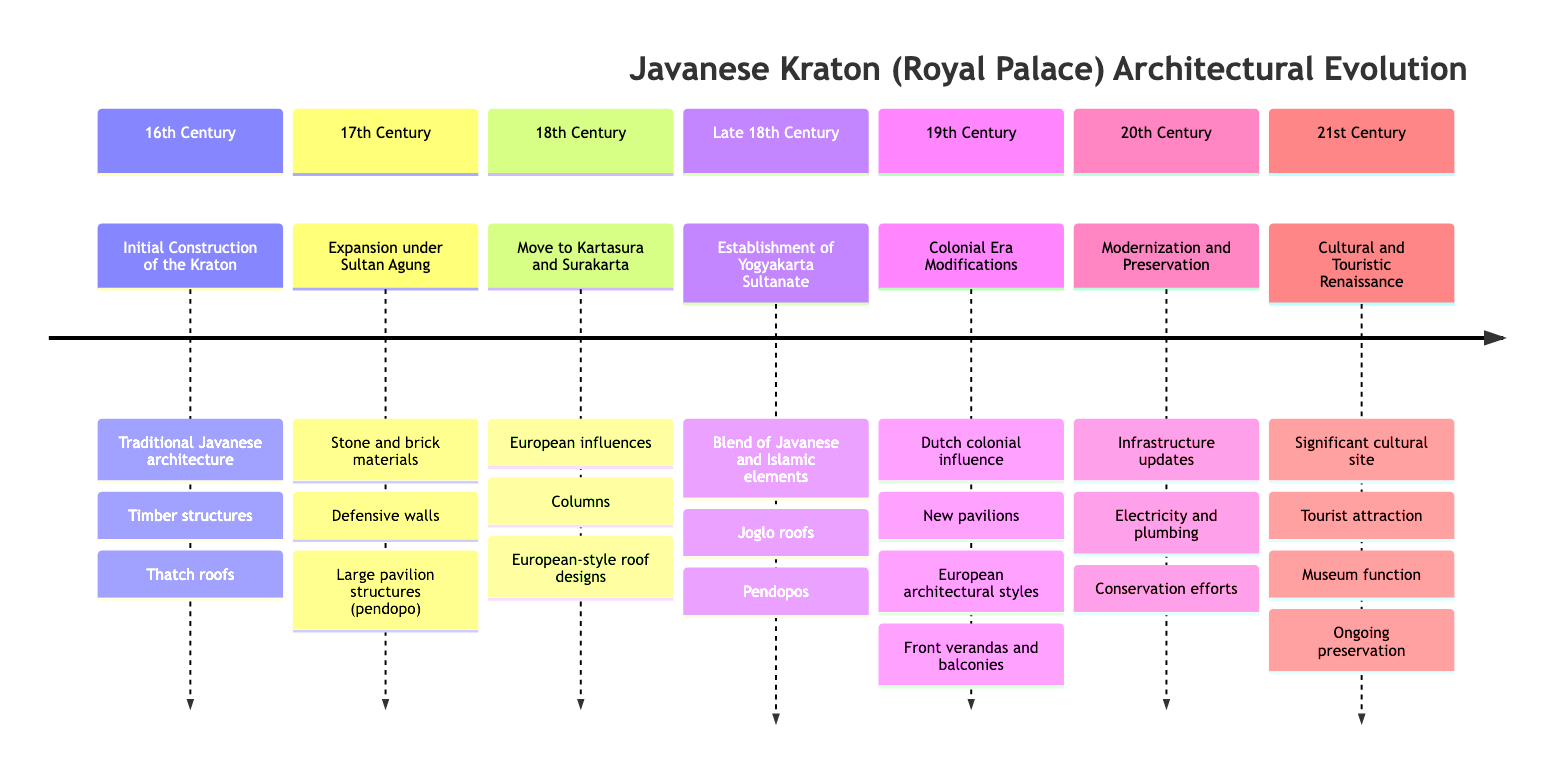What event marks the initial construction of the Kraton? The diagram states that the initial construction of the Kraton occurred in the 16th Century under Panembahan Senopati.
Answer: Initial Construction of the Kraton Which century saw the incorporation of European-style roof designs? By examining the timeline, it's noted that the integration of European influences, including roof designs, occurred in the 18th Century when the Kraton was moved to Kartasura and Surakarta.
Answer: 18th Century What structural feature was primarily expanded during Sultan Agung's reign in the 17th Century? The diagram indicates that during Sultan Agung's reign, the Kraton was expanded to include large pavilion structures known as pendopo, which is a significant detail in that century.
Answer: Large pavilion structures (pendopo) How many events are listed in the 19th Century? By counting the events in the timeline for the 19th Century, it shows that there is only one specific event detailing the Dutch colonial modifications.
Answer: 1 What architectural elements are mentioned as part of the Yogyakarta Kraton established in the Late 18th Century? The details provided in the diagram for the Yogyakarta Sultanate mention a blend of traditional Javanese and Islamic elements, specifically joglo roofs and pendopos.
Answer: Joglo roofs and pendopos During which century did modernization and preservation efforts take place? According to the timeline, the 20th Century is specifically noted for efforts in modernization and preservation of the Kraton, detailing infrastructure updates.
Answer: 20th Century What significant role does the Kraton play in the 21st Century? The timeline emphasizes that in the 21st Century, the Kraton serves not only as a touristic site but also functions as a cultural site and museum, illustrating its ongoing significance.
Answer: Significant cultural site What material was predominantly used in the Kraton's expansion in the 17th Century? The diagram reveals that stone and brick materials were primarily used for the expansion of the Kraton during the reign of Sultan Agung in the 17th Century.
Answer: Stone and brick materials Which event led to the establishment of a separate Sultanate in the Late 18th Century? As indicated in the diagram, the Giyanti Agreement of 1755 was the pivotal event that resulted in the establishment of the Yogyakarta Sultanate.
Answer: Giyanti Agreement 